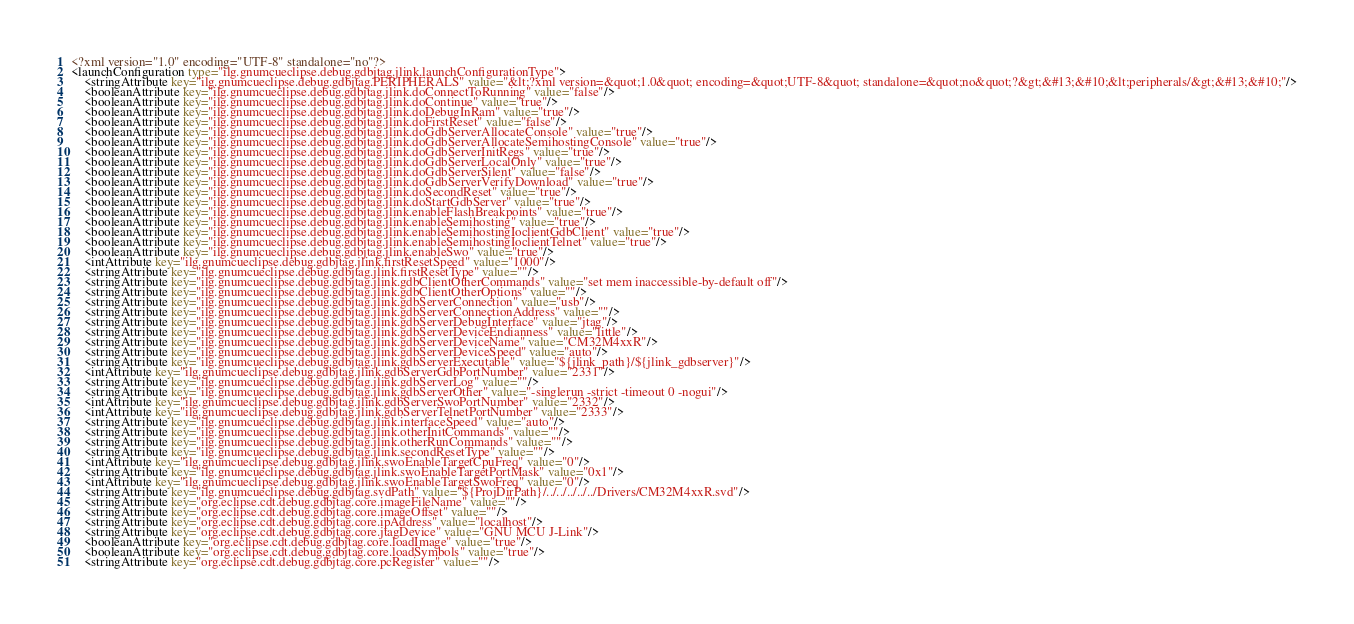Convert code to text. <code><loc_0><loc_0><loc_500><loc_500><_XML_><?xml version="1.0" encoding="UTF-8" standalone="no"?>
<launchConfiguration type="ilg.gnumcueclipse.debug.gdbjtag.jlink.launchConfigurationType">
    <stringAttribute key="ilg.gnumcueclipse.debug.gdbjtag.PERIPHERALS" value="&lt;?xml version=&quot;1.0&quot; encoding=&quot;UTF-8&quot; standalone=&quot;no&quot;?&gt;&#13;&#10;&lt;peripherals/&gt;&#13;&#10;"/>
    <booleanAttribute key="ilg.gnumcueclipse.debug.gdbjtag.jlink.doConnectToRunning" value="false"/>
    <booleanAttribute key="ilg.gnumcueclipse.debug.gdbjtag.jlink.doContinue" value="true"/>
    <booleanAttribute key="ilg.gnumcueclipse.debug.gdbjtag.jlink.doDebugInRam" value="true"/>
    <booleanAttribute key="ilg.gnumcueclipse.debug.gdbjtag.jlink.doFirstReset" value="false"/>
    <booleanAttribute key="ilg.gnumcueclipse.debug.gdbjtag.jlink.doGdbServerAllocateConsole" value="true"/>
    <booleanAttribute key="ilg.gnumcueclipse.debug.gdbjtag.jlink.doGdbServerAllocateSemihostingConsole" value="true"/>
    <booleanAttribute key="ilg.gnumcueclipse.debug.gdbjtag.jlink.doGdbServerInitRegs" value="true"/>
    <booleanAttribute key="ilg.gnumcueclipse.debug.gdbjtag.jlink.doGdbServerLocalOnly" value="true"/>
    <booleanAttribute key="ilg.gnumcueclipse.debug.gdbjtag.jlink.doGdbServerSilent" value="false"/>
    <booleanAttribute key="ilg.gnumcueclipse.debug.gdbjtag.jlink.doGdbServerVerifyDownload" value="true"/>
    <booleanAttribute key="ilg.gnumcueclipse.debug.gdbjtag.jlink.doSecondReset" value="true"/>
    <booleanAttribute key="ilg.gnumcueclipse.debug.gdbjtag.jlink.doStartGdbServer" value="true"/>
    <booleanAttribute key="ilg.gnumcueclipse.debug.gdbjtag.jlink.enableFlashBreakpoints" value="true"/>
    <booleanAttribute key="ilg.gnumcueclipse.debug.gdbjtag.jlink.enableSemihosting" value="true"/>
    <booleanAttribute key="ilg.gnumcueclipse.debug.gdbjtag.jlink.enableSemihostingIoclientGdbClient" value="true"/>
    <booleanAttribute key="ilg.gnumcueclipse.debug.gdbjtag.jlink.enableSemihostingIoclientTelnet" value="true"/>
    <booleanAttribute key="ilg.gnumcueclipse.debug.gdbjtag.jlink.enableSwo" value="true"/>
    <intAttribute key="ilg.gnumcueclipse.debug.gdbjtag.jlink.firstResetSpeed" value="1000"/>
    <stringAttribute key="ilg.gnumcueclipse.debug.gdbjtag.jlink.firstResetType" value=""/>
    <stringAttribute key="ilg.gnumcueclipse.debug.gdbjtag.jlink.gdbClientOtherCommands" value="set mem inaccessible-by-default off"/>
    <stringAttribute key="ilg.gnumcueclipse.debug.gdbjtag.jlink.gdbClientOtherOptions" value=""/>
    <stringAttribute key="ilg.gnumcueclipse.debug.gdbjtag.jlink.gdbServerConnection" value="usb"/>
    <stringAttribute key="ilg.gnumcueclipse.debug.gdbjtag.jlink.gdbServerConnectionAddress" value=""/>
    <stringAttribute key="ilg.gnumcueclipse.debug.gdbjtag.jlink.gdbServerDebugInterface" value="jtag"/>
    <stringAttribute key="ilg.gnumcueclipse.debug.gdbjtag.jlink.gdbServerDeviceEndianness" value="little"/>
    <stringAttribute key="ilg.gnumcueclipse.debug.gdbjtag.jlink.gdbServerDeviceName" value="CM32M4xxR"/>
    <stringAttribute key="ilg.gnumcueclipse.debug.gdbjtag.jlink.gdbServerDeviceSpeed" value="auto"/>
    <stringAttribute key="ilg.gnumcueclipse.debug.gdbjtag.jlink.gdbServerExecutable" value="${jlink_path}/${jlink_gdbserver}"/>
    <intAttribute key="ilg.gnumcueclipse.debug.gdbjtag.jlink.gdbServerGdbPortNumber" value="2331"/>
    <stringAttribute key="ilg.gnumcueclipse.debug.gdbjtag.jlink.gdbServerLog" value=""/>
    <stringAttribute key="ilg.gnumcueclipse.debug.gdbjtag.jlink.gdbServerOther" value="-singlerun -strict -timeout 0 -nogui"/>
    <intAttribute key="ilg.gnumcueclipse.debug.gdbjtag.jlink.gdbServerSwoPortNumber" value="2332"/>
    <intAttribute key="ilg.gnumcueclipse.debug.gdbjtag.jlink.gdbServerTelnetPortNumber" value="2333"/>
    <stringAttribute key="ilg.gnumcueclipse.debug.gdbjtag.jlink.interfaceSpeed" value="auto"/>
    <stringAttribute key="ilg.gnumcueclipse.debug.gdbjtag.jlink.otherInitCommands" value=""/>
    <stringAttribute key="ilg.gnumcueclipse.debug.gdbjtag.jlink.otherRunCommands" value=""/>
    <stringAttribute key="ilg.gnumcueclipse.debug.gdbjtag.jlink.secondResetType" value=""/>
    <intAttribute key="ilg.gnumcueclipse.debug.gdbjtag.jlink.swoEnableTargetCpuFreq" value="0"/>
    <stringAttribute key="ilg.gnumcueclipse.debug.gdbjtag.jlink.swoEnableTargetPortMask" value="0x1"/>
    <intAttribute key="ilg.gnumcueclipse.debug.gdbjtag.jlink.swoEnableTargetSwoFreq" value="0"/>
    <stringAttribute key="ilg.gnumcueclipse.debug.gdbjtag.svdPath" value="${ProjDirPath}/../../../../../Drivers/CM32M4xxR.svd"/>
    <stringAttribute key="org.eclipse.cdt.debug.gdbjtag.core.imageFileName" value=""/>
    <stringAttribute key="org.eclipse.cdt.debug.gdbjtag.core.imageOffset" value=""/>
    <stringAttribute key="org.eclipse.cdt.debug.gdbjtag.core.ipAddress" value="localhost"/>
    <stringAttribute key="org.eclipse.cdt.debug.gdbjtag.core.jtagDevice" value="GNU MCU J-Link"/>
    <booleanAttribute key="org.eclipse.cdt.debug.gdbjtag.core.loadImage" value="true"/>
    <booleanAttribute key="org.eclipse.cdt.debug.gdbjtag.core.loadSymbols" value="true"/>
    <stringAttribute key="org.eclipse.cdt.debug.gdbjtag.core.pcRegister" value=""/></code> 